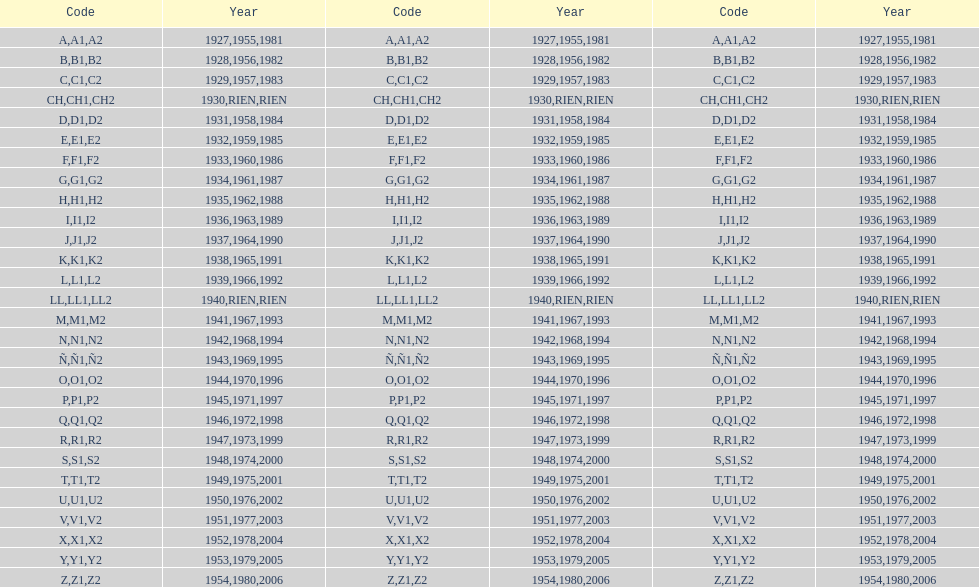During which year was the "ch" code exclusively employed? 1930. 